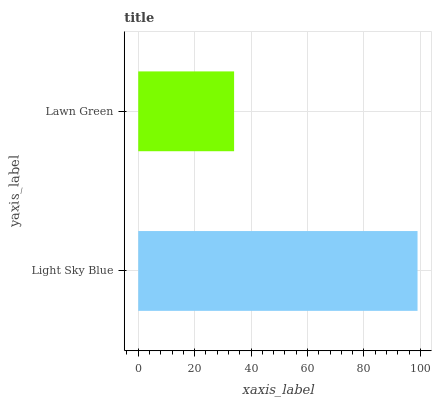Is Lawn Green the minimum?
Answer yes or no. Yes. Is Light Sky Blue the maximum?
Answer yes or no. Yes. Is Lawn Green the maximum?
Answer yes or no. No. Is Light Sky Blue greater than Lawn Green?
Answer yes or no. Yes. Is Lawn Green less than Light Sky Blue?
Answer yes or no. Yes. Is Lawn Green greater than Light Sky Blue?
Answer yes or no. No. Is Light Sky Blue less than Lawn Green?
Answer yes or no. No. Is Light Sky Blue the high median?
Answer yes or no. Yes. Is Lawn Green the low median?
Answer yes or no. Yes. Is Lawn Green the high median?
Answer yes or no. No. Is Light Sky Blue the low median?
Answer yes or no. No. 